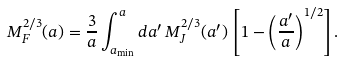Convert formula to latex. <formula><loc_0><loc_0><loc_500><loc_500>M _ { F } ^ { 2 / 3 } ( a ) = \frac { 3 } { a } \int _ { a _ { \min } } ^ { a } d a ^ { \prime } \, M _ { J } ^ { 2 / 3 } ( a ^ { \prime } ) \, \left [ 1 - \left ( \frac { a ^ { \prime } } { a } \right ) ^ { 1 / 2 } \right ] .</formula> 